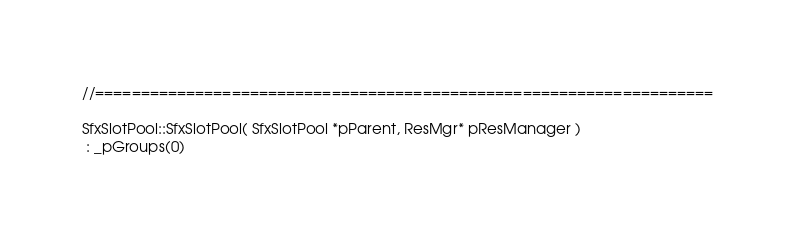Convert code to text. <code><loc_0><loc_0><loc_500><loc_500><_C++_>
//====================================================================

SfxSlotPool::SfxSlotPool( SfxSlotPool *pParent, ResMgr* pResManager )
 : _pGroups(0)</code> 